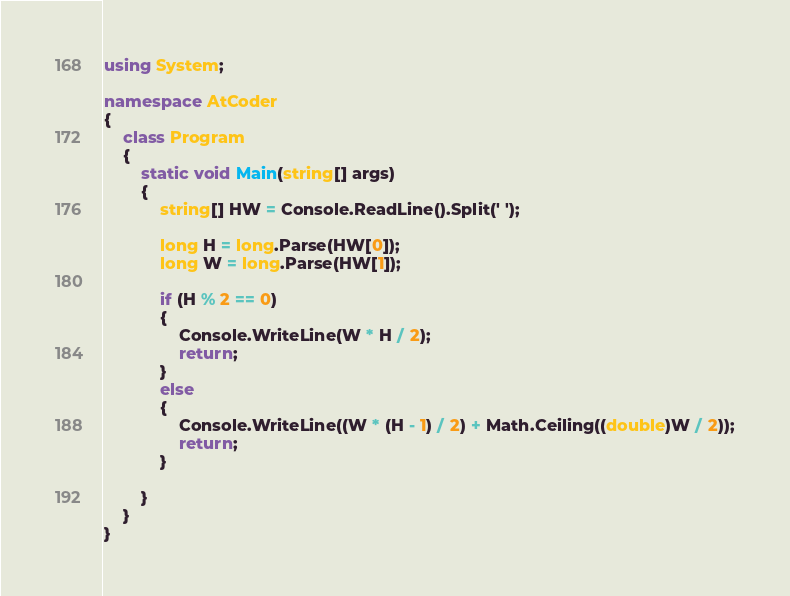<code> <loc_0><loc_0><loc_500><loc_500><_C#_>using System;

namespace AtCoder
{
    class Program
    {
        static void Main(string[] args)
        {
            string[] HW = Console.ReadLine().Split(' ');

            long H = long.Parse(HW[0]);
            long W = long.Parse(HW[1]);

            if (H % 2 == 0)
            {
                Console.WriteLine(W * H / 2);
                return;
            }
            else
            {
                Console.WriteLine((W * (H - 1) / 2) + Math.Ceiling((double)W / 2));
                return;
            }

        }
    }
}
</code> 